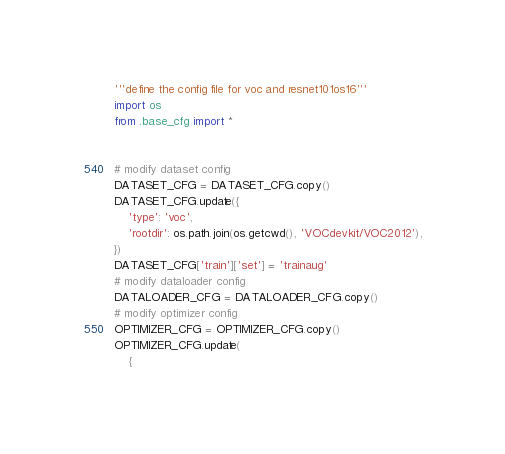Convert code to text. <code><loc_0><loc_0><loc_500><loc_500><_Python_>'''define the config file for voc and resnet101os16'''
import os
from .base_cfg import *


# modify dataset config
DATASET_CFG = DATASET_CFG.copy()
DATASET_CFG.update({
    'type': 'voc',
    'rootdir': os.path.join(os.getcwd(), 'VOCdevkit/VOC2012'),
})
DATASET_CFG['train']['set'] = 'trainaug'
# modify dataloader config
DATALOADER_CFG = DATALOADER_CFG.copy()
# modify optimizer config
OPTIMIZER_CFG = OPTIMIZER_CFG.copy()
OPTIMIZER_CFG.update(
    {</code> 